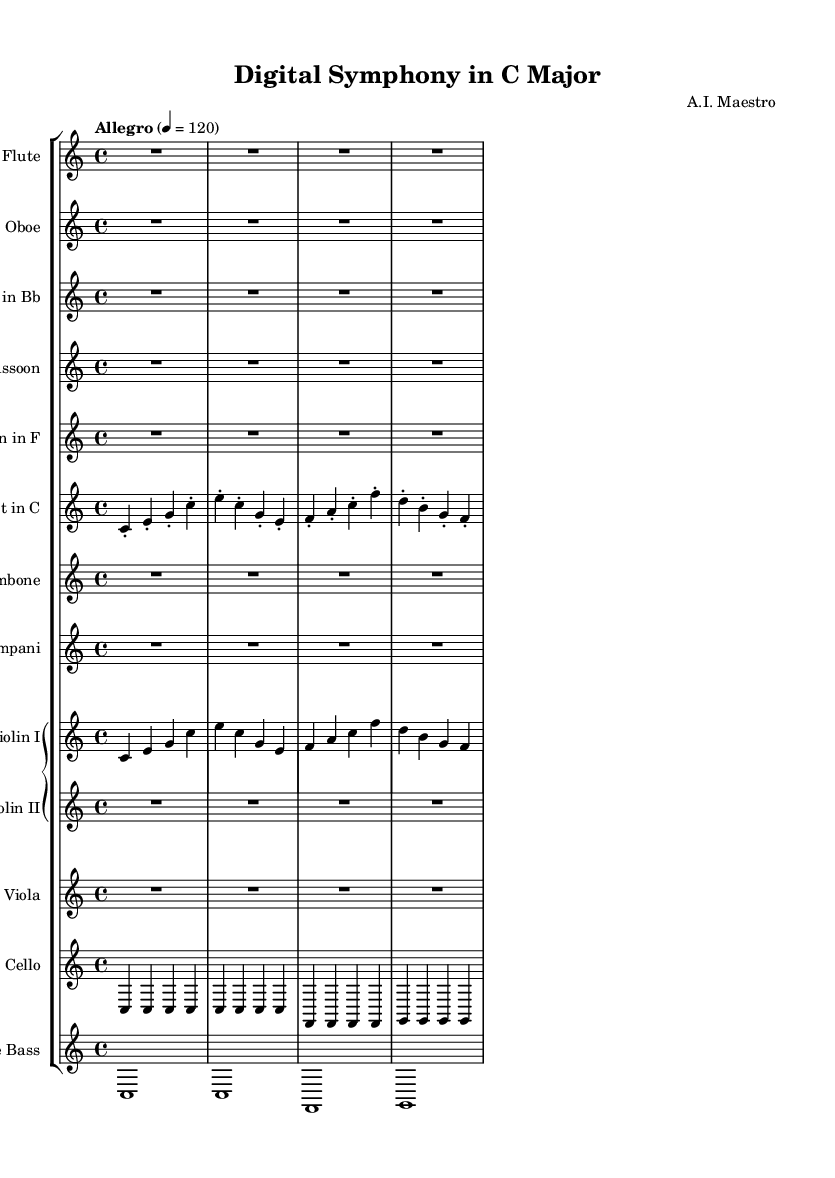What is the key signature of this music? The key signature is indicated at the beginning of the staff and is C major, which has no sharps or flats, as there are no accidentals shown.
Answer: C major What is the time signature of the piece? The time signature is indicated at the beginning of the score and is 4/4, meaning there are four beats in each measure.
Answer: 4/4 What is the tempo marking for this composition? The tempo marking is indicated in the score with "Allegro," which specifies the intended speed of the performance; the specific metronome marking is 120 beats per minute.
Answer: Allegro How many measures are in the first violin part? By counting the distinct groups of notes separated by bar lines in the violin I part, there are four measures total, as indicated by the division of the music into segments.
Answer: 4 Which instruments have rests in their parts? The flute, oboe, clarinet, bassoon, trombone, and timpani parts are all marked with rests (R1) for the entirety of the first section, indicating they do not play during this time.
Answer: Flute, Oboe, Clarinet, Bassoon, Trombone, Timpani What are the first three notes played by the trumpet? The first three notes played by the trumpet are C, E, and G, as indicated in the sheet music of the trumpet part at the beginning of the score.
Answer: C, E, G What type of composition is this? This piece is a symphonic composition as it is intended for performance by an orchestra, and it is labeled as "Digital Symphony," which indicates a specific blend of classical and technological elements.
Answer: Digital Symphony 